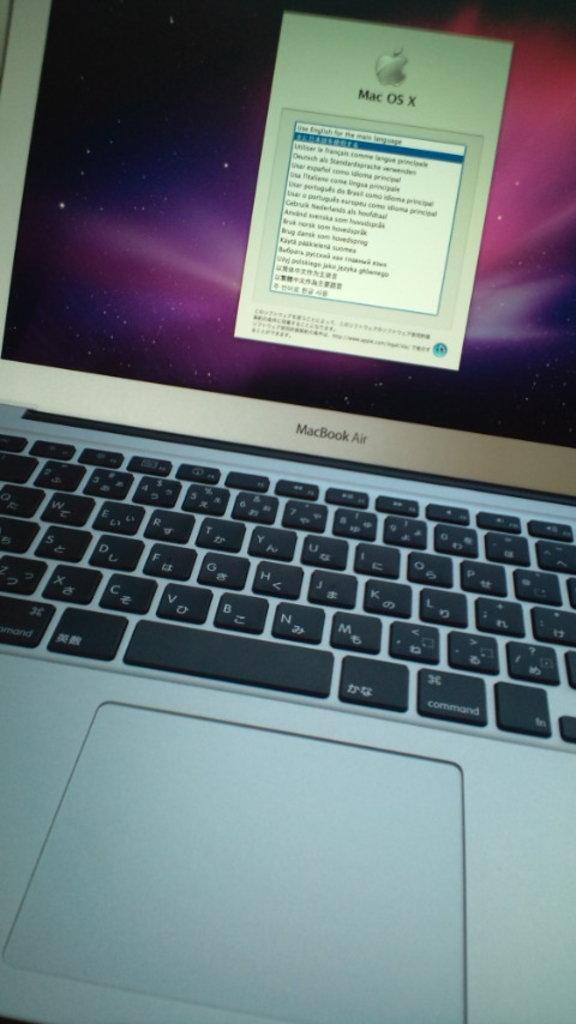Which operating system is the computer running?
Provide a short and direct response. Mac os x. What is the computer's name?
Provide a short and direct response. Macbook air. 